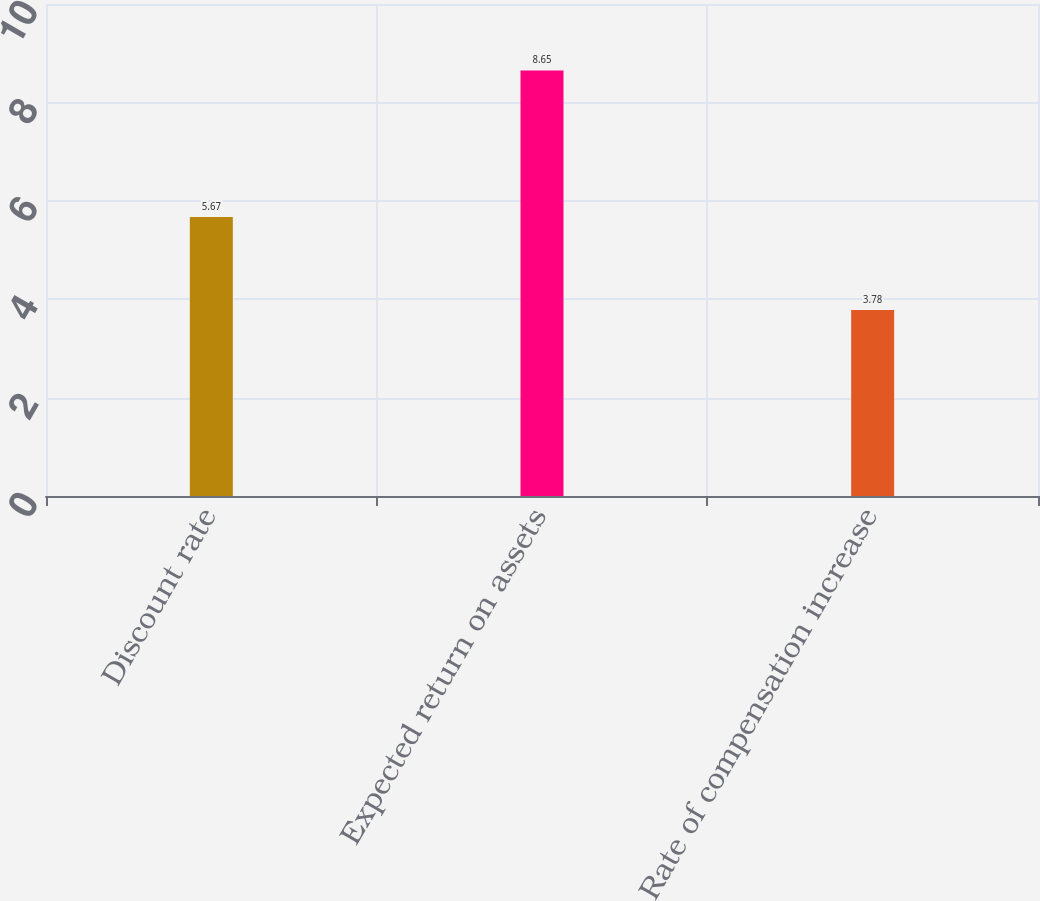Convert chart to OTSL. <chart><loc_0><loc_0><loc_500><loc_500><bar_chart><fcel>Discount rate<fcel>Expected return on assets<fcel>Rate of compensation increase<nl><fcel>5.67<fcel>8.65<fcel>3.78<nl></chart> 